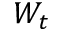Convert formula to latex. <formula><loc_0><loc_0><loc_500><loc_500>W _ { t }</formula> 